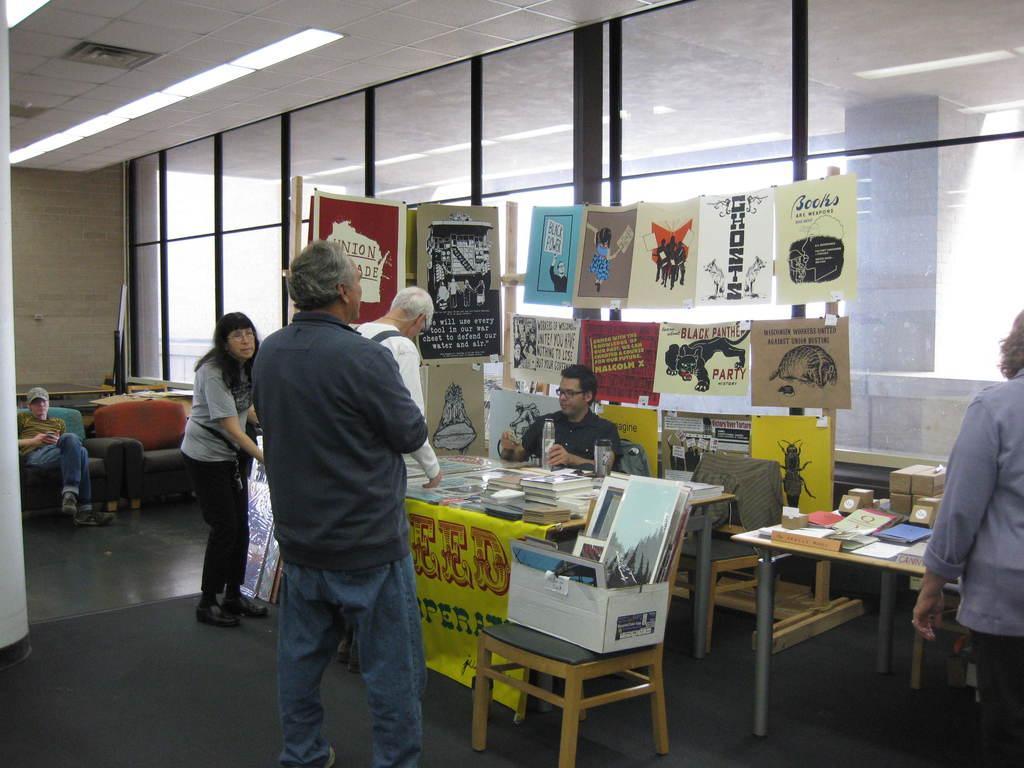In one or two sentences, can you explain what this image depicts? This picture shows a man seated on the chair and we see few posts on the glass and we see a box and few papers on the table and we see few people standing in front of the store and watching it and we see a man seated on the side 